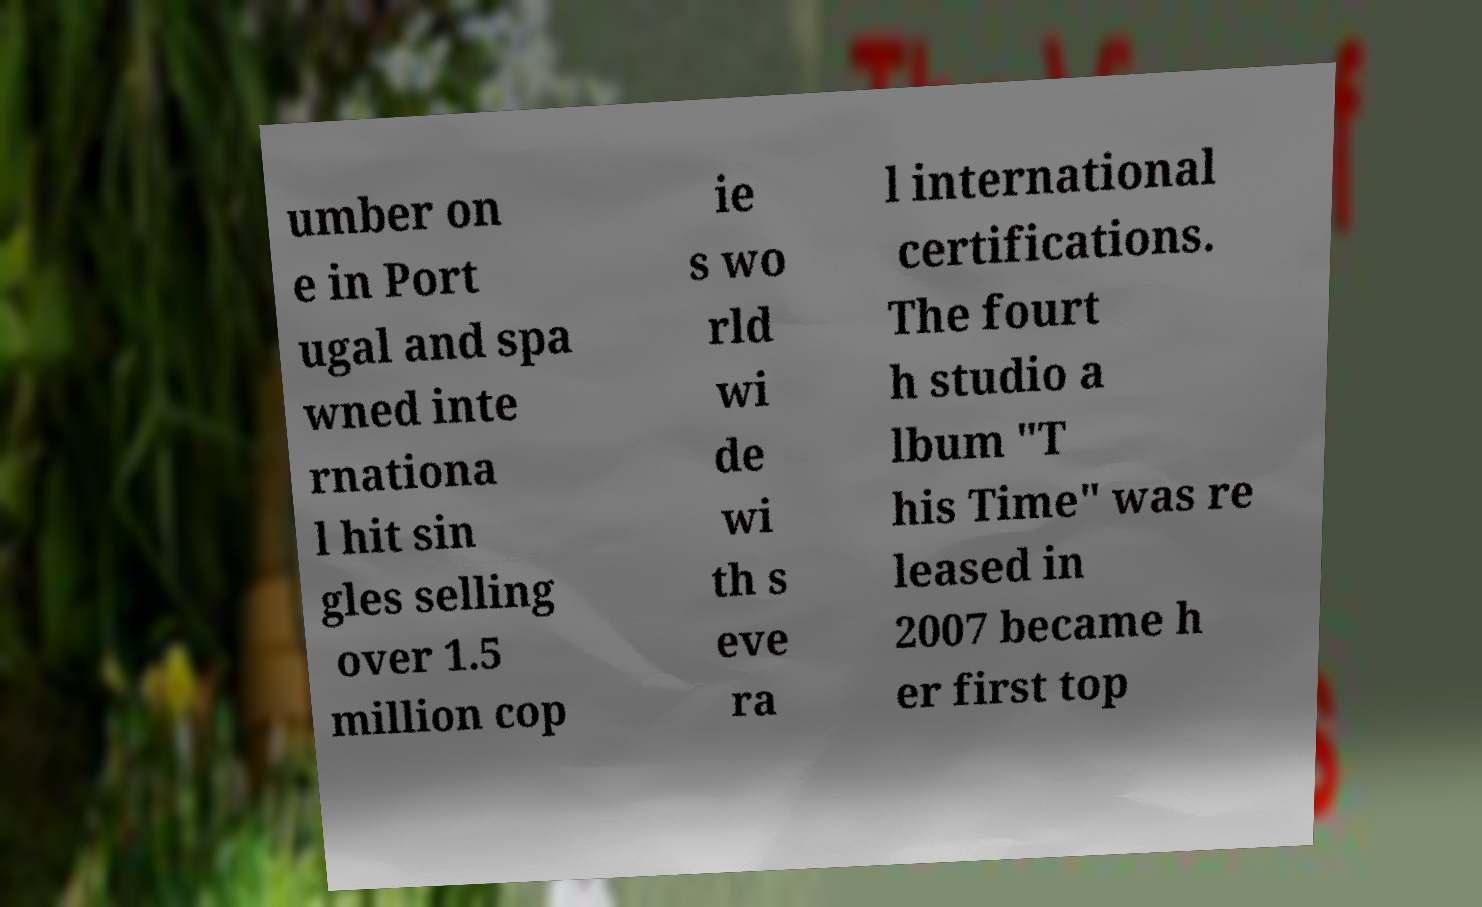For documentation purposes, I need the text within this image transcribed. Could you provide that? umber on e in Port ugal and spa wned inte rnationa l hit sin gles selling over 1.5 million cop ie s wo rld wi de wi th s eve ra l international certifications. The fourt h studio a lbum "T his Time" was re leased in 2007 became h er first top 